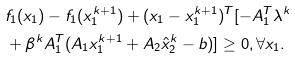<formula> <loc_0><loc_0><loc_500><loc_500>& f _ { 1 } ( x _ { 1 } ) - f _ { 1 } ( x ^ { k + 1 } _ { 1 } ) + ( x _ { 1 } - x _ { 1 } ^ { k + 1 } ) ^ { T } [ - A _ { 1 } ^ { T } \lambda ^ { k } \\ & + \beta ^ { k } A _ { 1 } ^ { T } ( A _ { 1 } { x } _ { 1 } ^ { k + 1 } + A _ { 2 } \hat { x } _ { 2 } ^ { k } - b ) ] \geq 0 , \forall x _ { 1 } .</formula> 